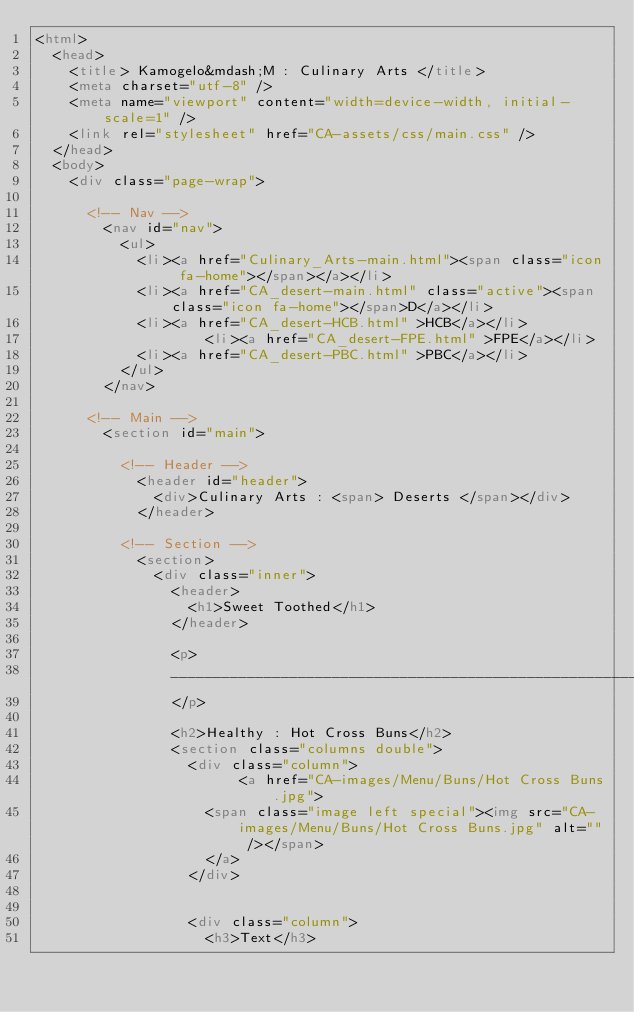<code> <loc_0><loc_0><loc_500><loc_500><_HTML_><html>
	<head>
		<title> Kamogelo&mdash;M : Culinary Arts </title>
		<meta charset="utf-8" />
		<meta name="viewport" content="width=device-width, initial-scale=1" />
		<link rel="stylesheet" href="CA-assets/css/main.css" />
	</head>
	<body>
		<div class="page-wrap">

			<!-- Nav -->
				<nav id="nav">
					<ul>
						<li><a href="Culinary_Arts-main.html"><span class="icon fa-home"></span></a></li>
						<li><a href="CA_desert-main.html" class="active"><span class="icon fa-home"></span>D</a></li>
						<li><a href="CA_desert-HCB.html" >HCB</a></li>
		                <li><a href="CA_desert-FPE.html" >FPE</a></li>
						<li><a href="CA_desert-PBC.html" >PBC</a></li>
					</ul>
				</nav>

			<!-- Main -->
				<section id="main">

					<!-- Header -->
						<header id="header">
							<div>Culinary Arts : <span> Deserts </span></div>
						</header>

					<!-- Section -->
						<section>
							<div class="inner">
								<header>
									<h1>Sweet Toothed</h1>
								</header>
								
								<p>
								_____________________________________________________________________________________________________________________
								</p>
								
								<h2>Healthy : Hot Cross Buns</h2>
								<section class="columns double">
									<div class="column">
								        <a href="CA-images/Menu/Buns/Hot Cross Buns.jpg">
										<span class="image left special"><img src="CA-images/Menu/Buns/Hot Cross Buns.jpg" alt="" /></span>
										</a>
									</div>
									
									
									<div class="column">
										<h3>Text</h3>
									    </code> 